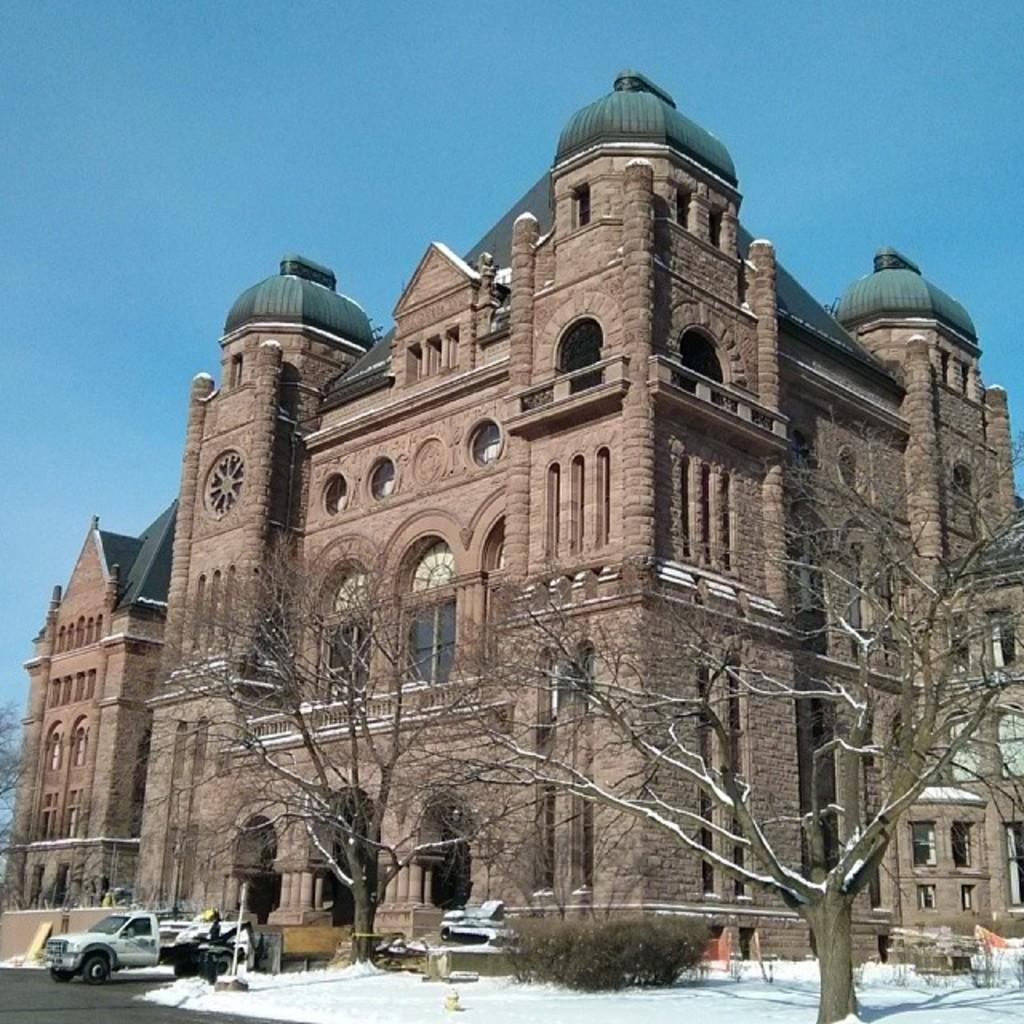What type of structure is present in the image? There is a building in the image. What architectural features can be seen on the building? The building has windows and arches. What else can be seen in the image besides the building? There are cars and trees visible in the image. What is the condition of the ground in the image? There is snow on the floor in the image. What type of crime is being committed in the image? There is no indication of any crime being committed in the image. Is there a yard or swing present in the image? No, there is no yard or swing visible in the image. 